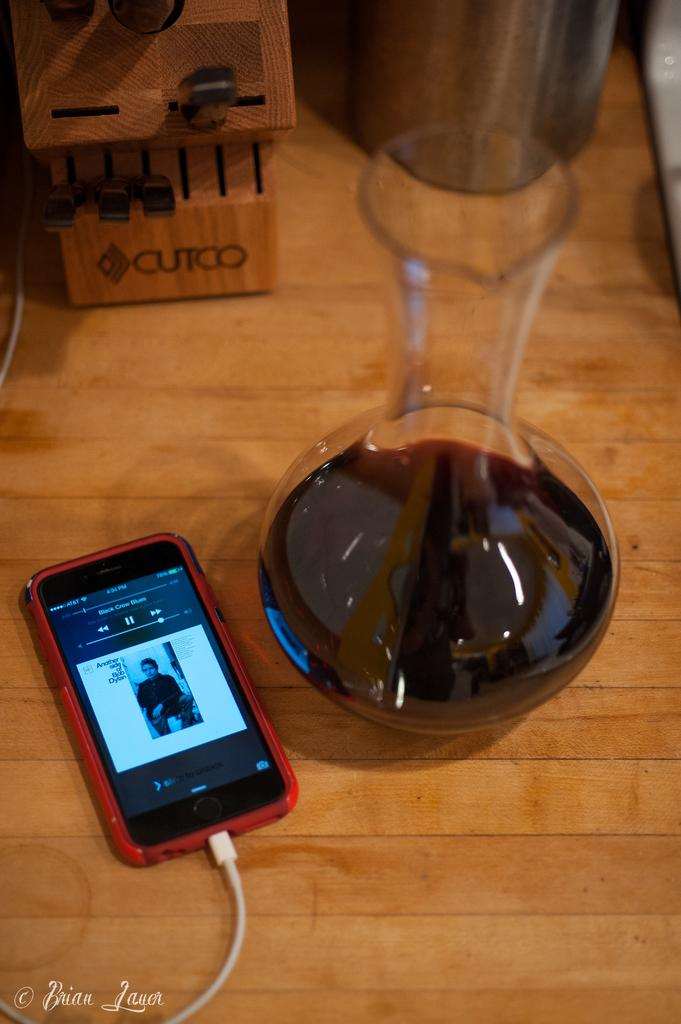<image>
Describe the image concisely. A red phone playing Black Crow Blues next to a vase of wine. 